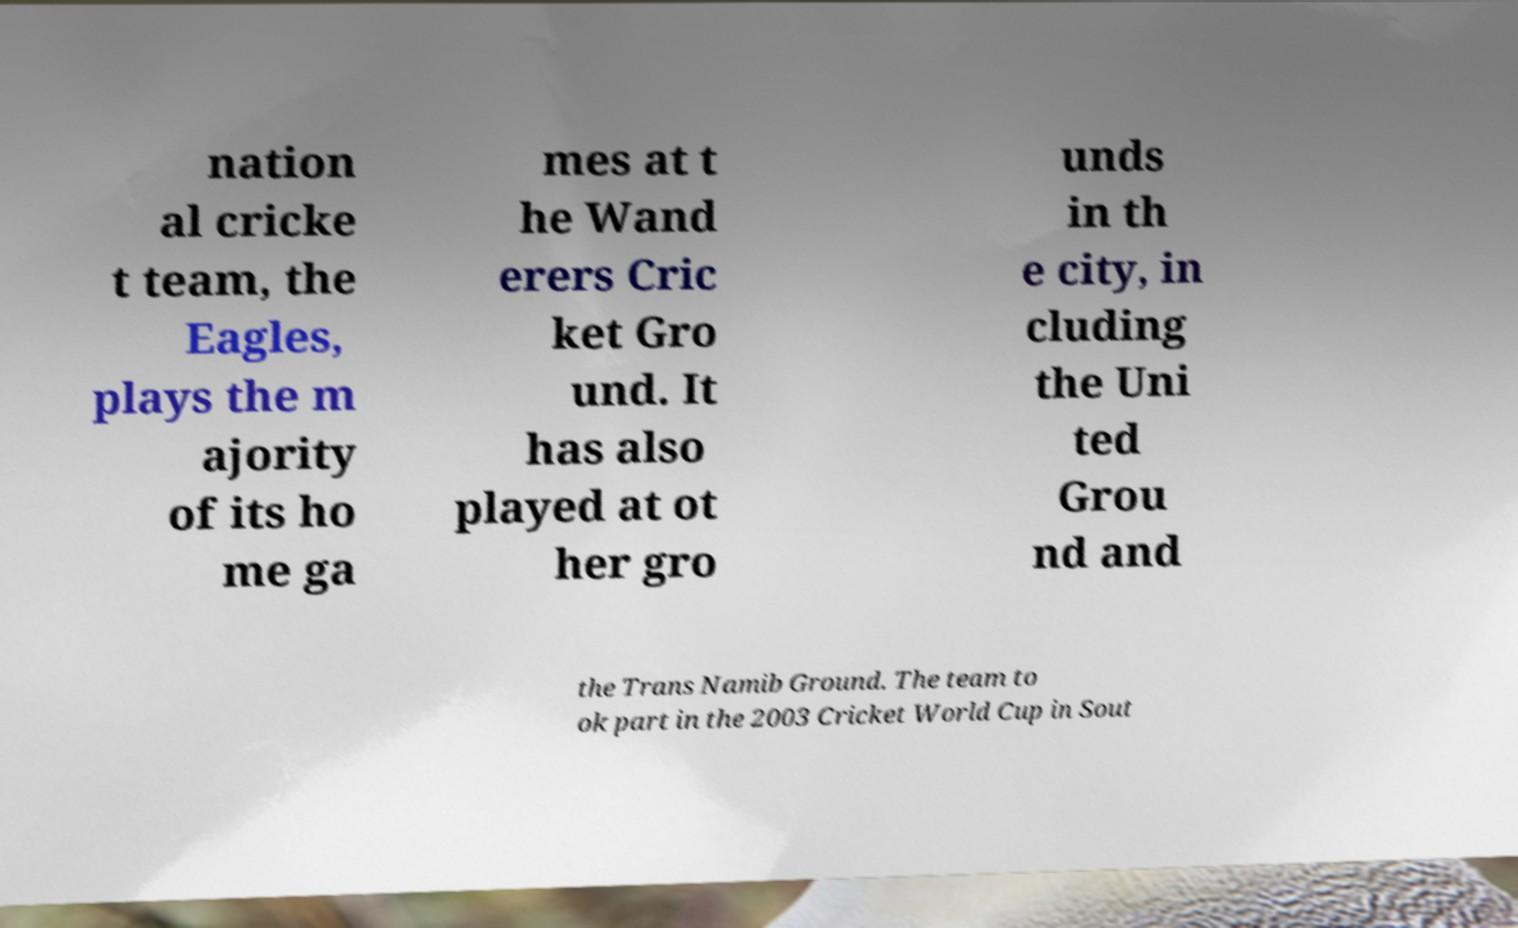Could you extract and type out the text from this image? nation al cricke t team, the Eagles, plays the m ajority of its ho me ga mes at t he Wand erers Cric ket Gro und. It has also played at ot her gro unds in th e city, in cluding the Uni ted Grou nd and the Trans Namib Ground. The team to ok part in the 2003 Cricket World Cup in Sout 